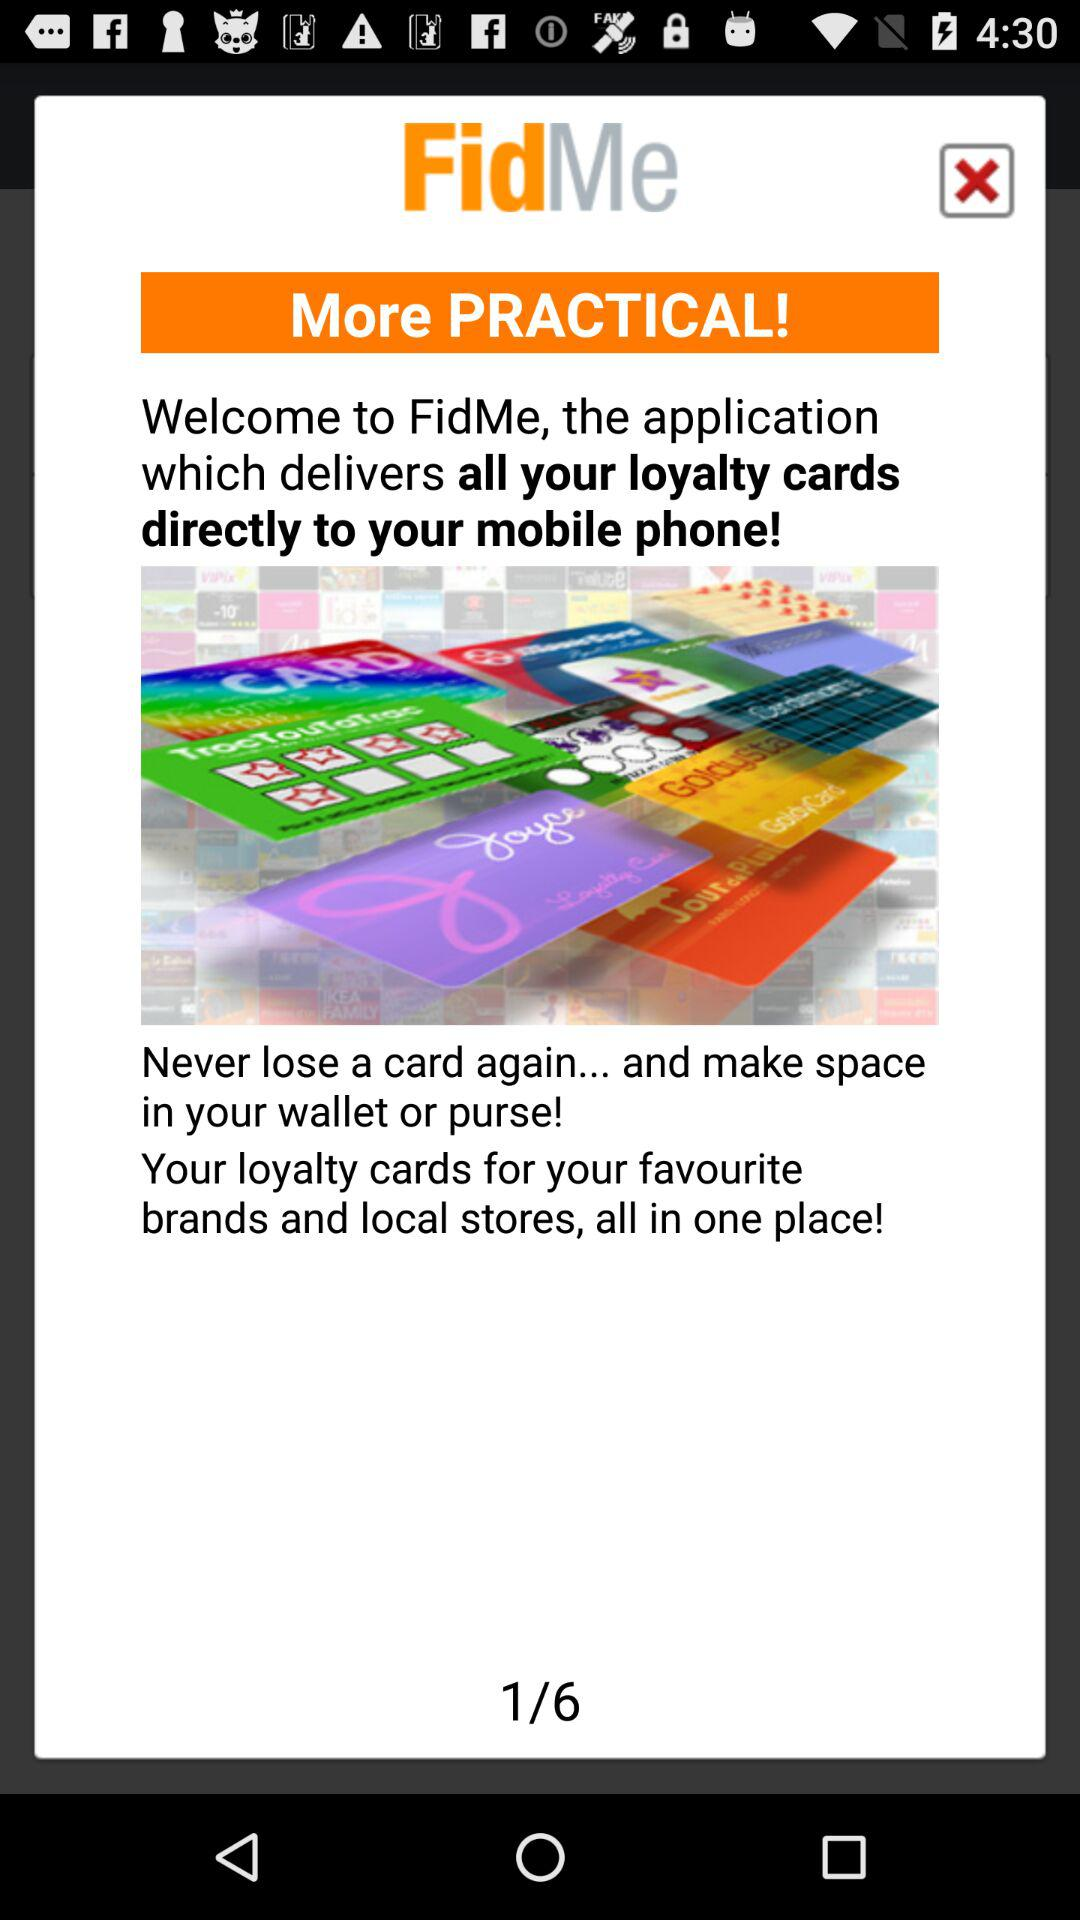At which page am I at? You are on page 1. 